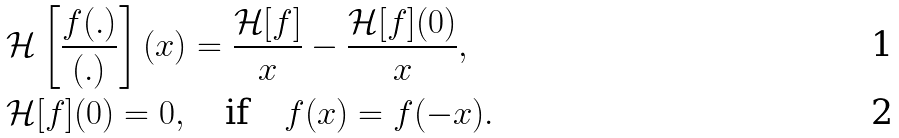Convert formula to latex. <formula><loc_0><loc_0><loc_500><loc_500>& \mathcal { H } \left [ \frac { f ( . ) } { ( . ) } \right ] ( x ) = \frac { \mathcal { H } [ f ] } { x } - \frac { \mathcal { H } [ f ] ( 0 ) } { x } , \\ & \mathcal { H } [ f ] ( 0 ) = 0 , \quad \text {if} \quad f ( x ) = f ( - x ) .</formula> 